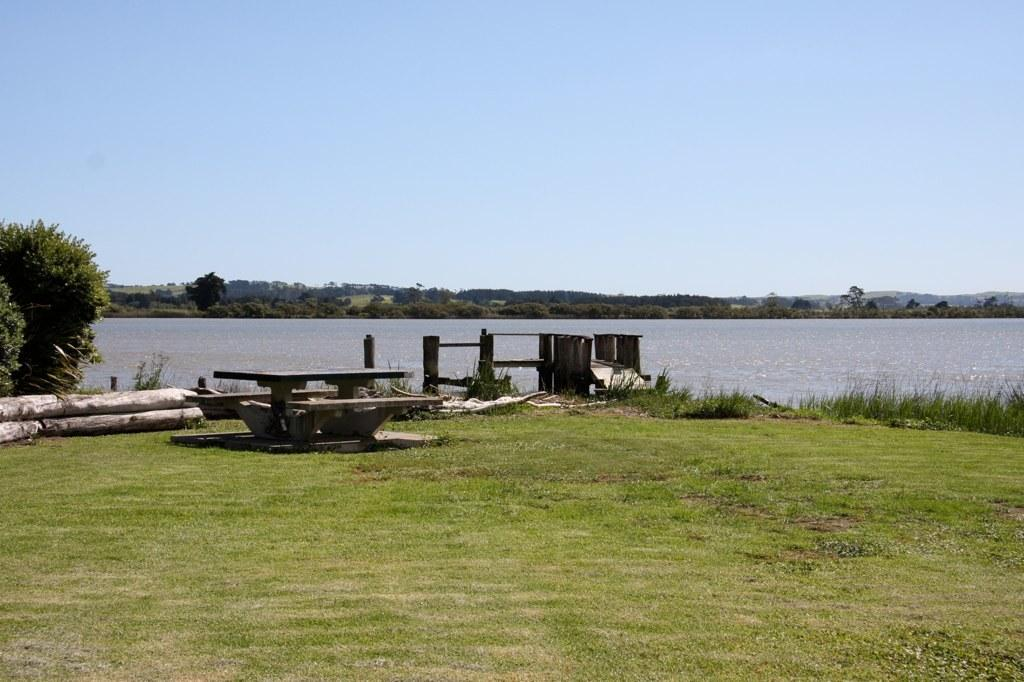What type of vegetation is visible in the front of the image? There is grass in the front of the image. What type of seating is present in the image? There is a bench in the image. What material are the logs made of in the image? The logs are made of wood. What is located on the left side of the image? There is a tree on the left side of the image. What is in the center of the image? There is water in the center of the image. What type of vegetation is visible at the back of the image? There are trees at the back of the image. How many rabbits are hopping on the bench in the image? There are no rabbits present in the image. What type of wound is visible on the tree in the image? There is no wound visible on the tree in the image. 